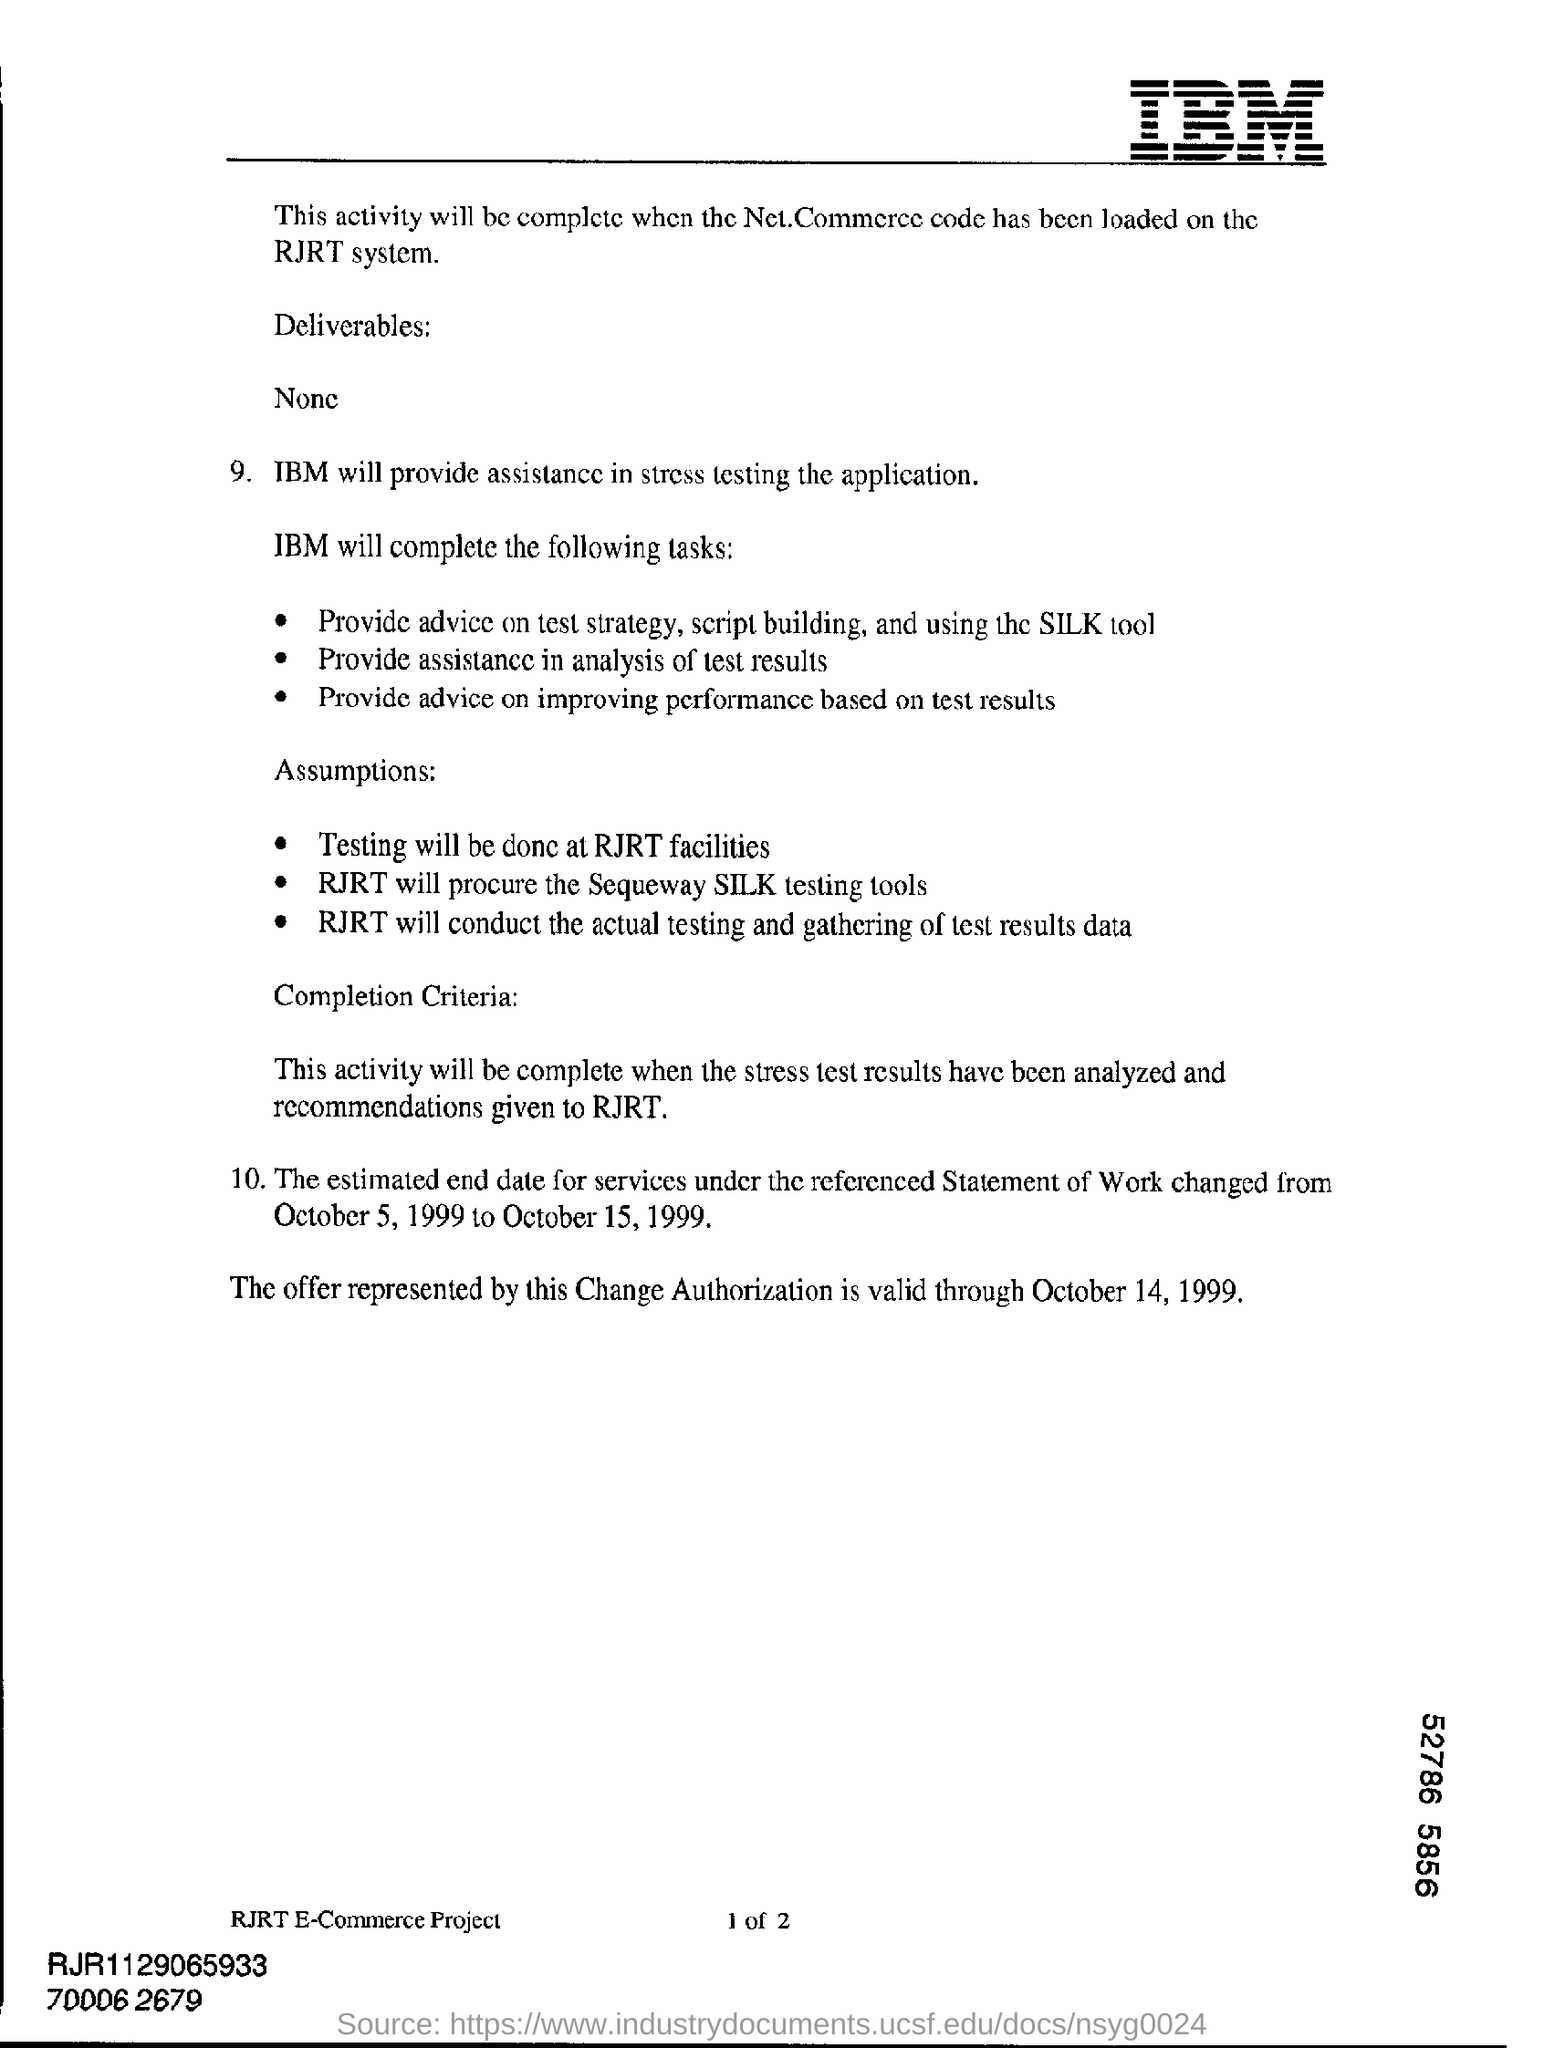Identify some key points in this picture. IBM is providing assistance in the form of stress testing. The offer represented by the change authorization is valid from October 14, 1999. 